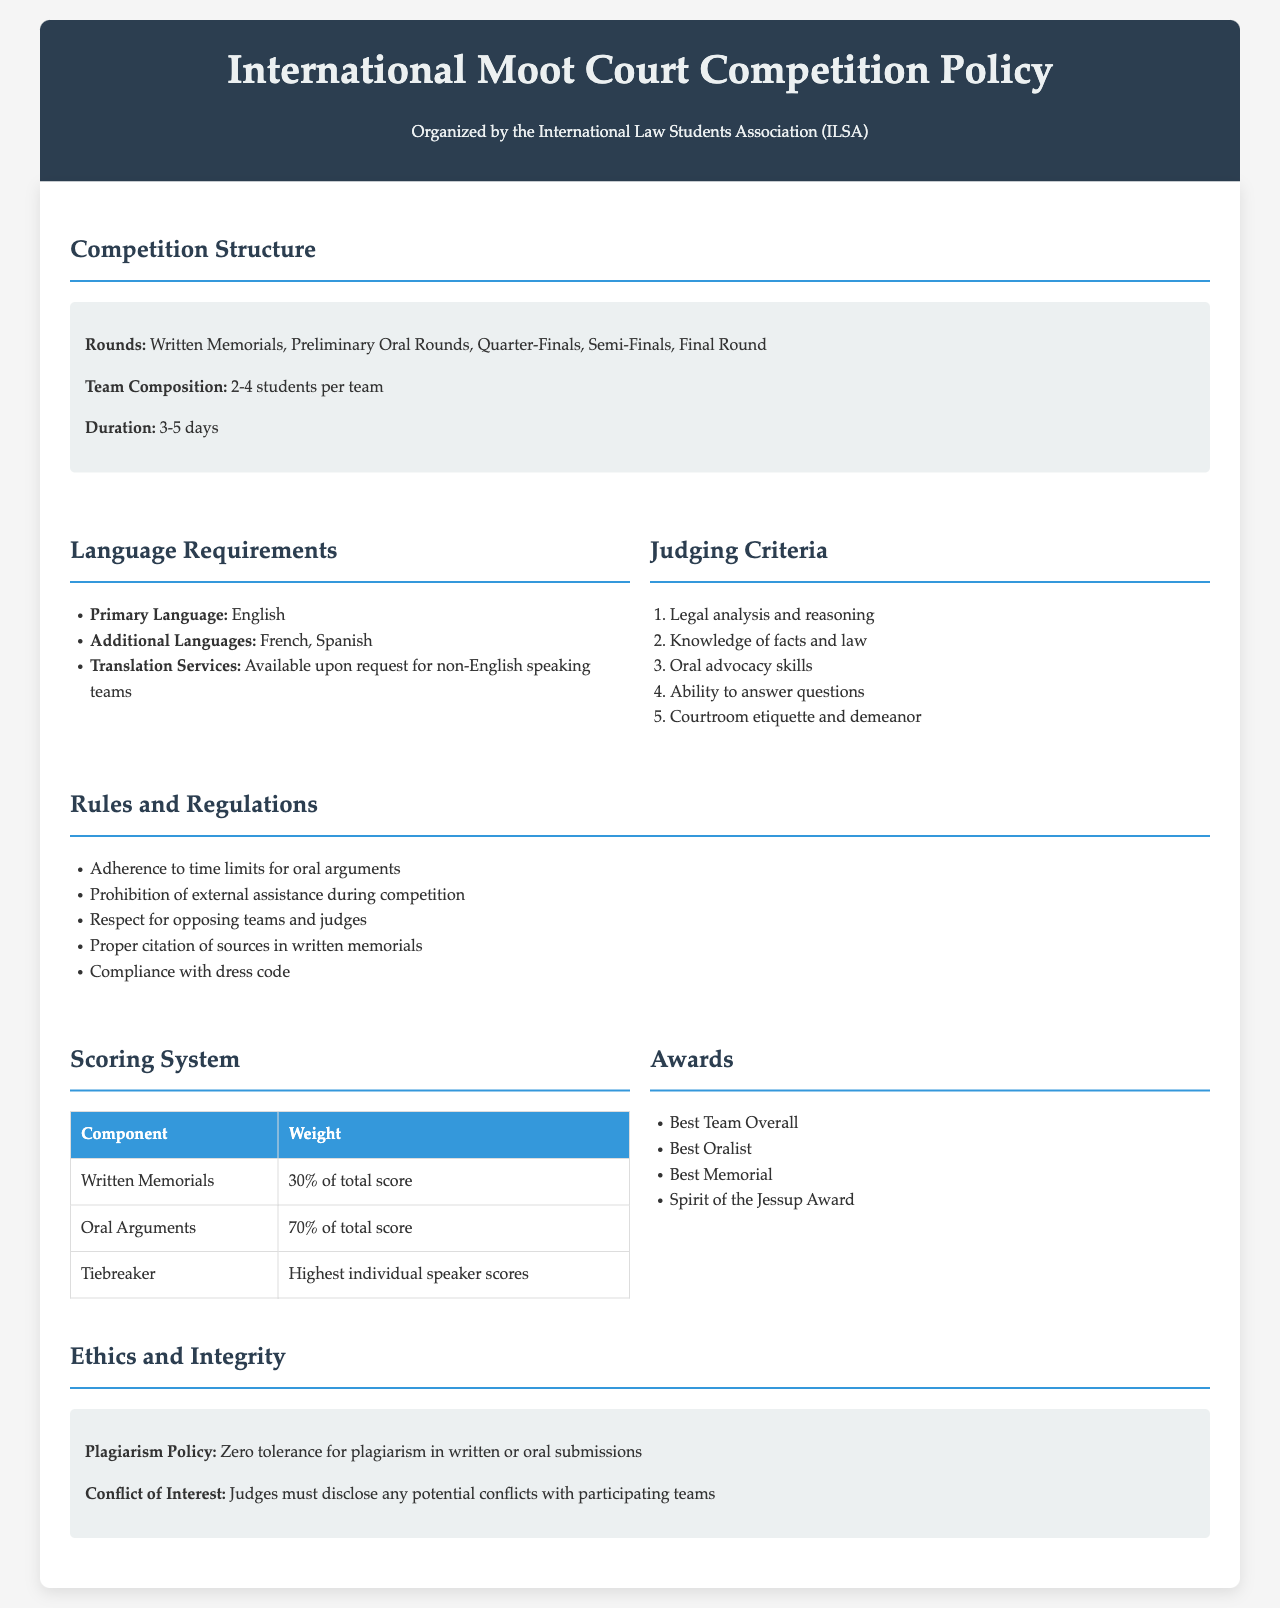What is the primary language of the competition? The primary language is specified in the document under Language Requirements.
Answer: English How many rounds are there in the competition? The number of rounds is outlined in the Competition Structure section.
Answer: Five What percentage of the total score is based on Oral Arguments? This is detailed in the Scoring System section of the document.
Answer: 70% What is the title of the policy document? The title is found at the top of the document.
Answer: International Moot Court Competition Policy What are the additional languages allowed? This information is found in the Language Requirements section.
Answer: French, Spanish Which award is specifically mentioned for team spirit? The award titles can be found in the Awards section.
Answer: Spirit of the Jessup Award What is the component that holds the highest weight in scoring? The Scoring System section specifies the components and their weight.
Answer: Oral Arguments How many students are allowed per team? This information is provided in the Competition Structure.
Answer: 2-4 students What is the plagiarism policy stated in the document? This policy can be found in the Ethics and Integrity section.
Answer: Zero tolerance for plagiarism 